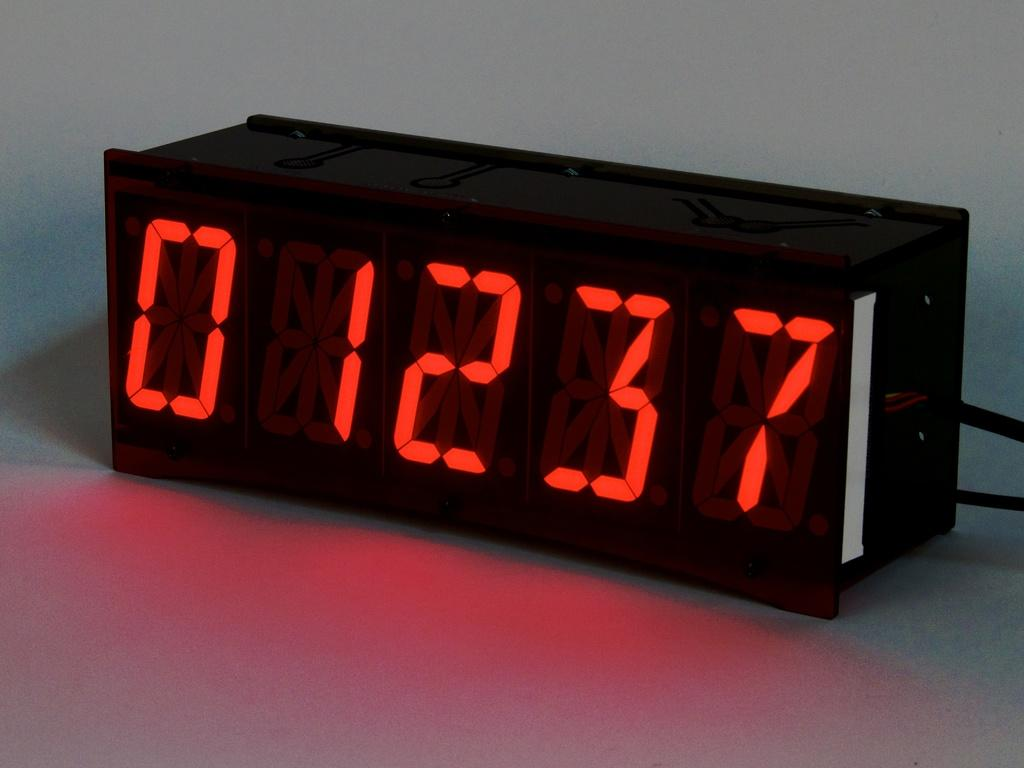<image>
Give a short and clear explanation of the subsequent image. A digital alarm clock that is light up and reads 01237. 